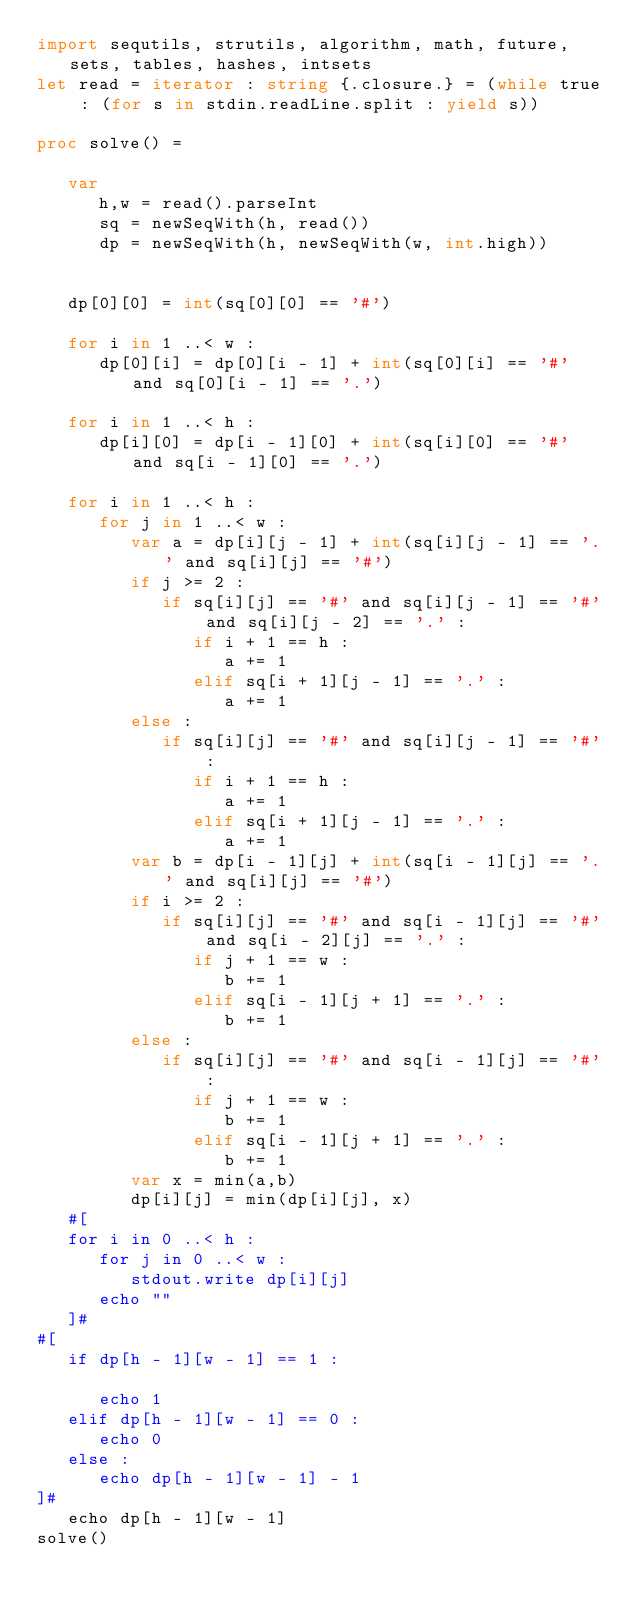<code> <loc_0><loc_0><loc_500><loc_500><_Nim_>import sequtils, strutils, algorithm, math, future, sets, tables, hashes, intsets
let read = iterator : string {.closure.} = (while true : (for s in stdin.readLine.split : yield s))

proc solve() =
   
   var
      h,w = read().parseInt
      sq = newSeqWith(h, read())
      dp = newSeqWith(h, newSeqWith(w, int.high))

   
   dp[0][0] = int(sq[0][0] == '#')

   for i in 1 ..< w : 
      dp[0][i] = dp[0][i - 1] + int(sq[0][i] == '#' and sq[0][i - 1] == '.') 

   for i in 1 ..< h : 
      dp[i][0] = dp[i - 1][0] + int(sq[i][0] == '#' and sq[i - 1][0] == '.')

   for i in 1 ..< h : 
      for j in 1 ..< w : 
         var a = dp[i][j - 1] + int(sq[i][j - 1] == '.' and sq[i][j] == '#')
         if j >= 2 :    
            if sq[i][j] == '#' and sq[i][j - 1] == '#' and sq[i][j - 2] == '.' : 
               if i + 1 == h : 
                  a += 1
               elif sq[i + 1][j - 1] == '.' : 
                  a += 1
         else : 
            if sq[i][j] == '#' and sq[i][j - 1] == '#' : 
               if i + 1 == h : 
                  a += 1
               elif sq[i + 1][j - 1] == '.' : 
                  a += 1
         var b = dp[i - 1][j] + int(sq[i - 1][j] == '.' and sq[i][j] == '#')
         if i >= 2 : 
            if sq[i][j] == '#' and sq[i - 1][j] == '#' and sq[i - 2][j] == '.' : 
               if j + 1 == w : 
                  b += 1
               elif sq[i - 1][j + 1] == '.' : 
                  b += 1
         else : 
            if sq[i][j] == '#' and sq[i - 1][j] == '#' : 
               if j + 1 == w : 
                  b += 1
               elif sq[i - 1][j + 1] == '.' : 
                  b += 1
         var x = min(a,b)
         dp[i][j] = min(dp[i][j], x)
   #[ 
   for i in 0 ..< h : 
      for j in 0 ..< w : 
         stdout.write dp[i][j]
      echo ""
   ]#
#[ 
   if dp[h - 1][w - 1] == 1 :

      echo 1
   elif dp[h - 1][w - 1] == 0 :
      echo 0
   else :
      echo dp[h - 1][w - 1] - 1
]#
   echo dp[h - 1][w - 1]
solve()</code> 